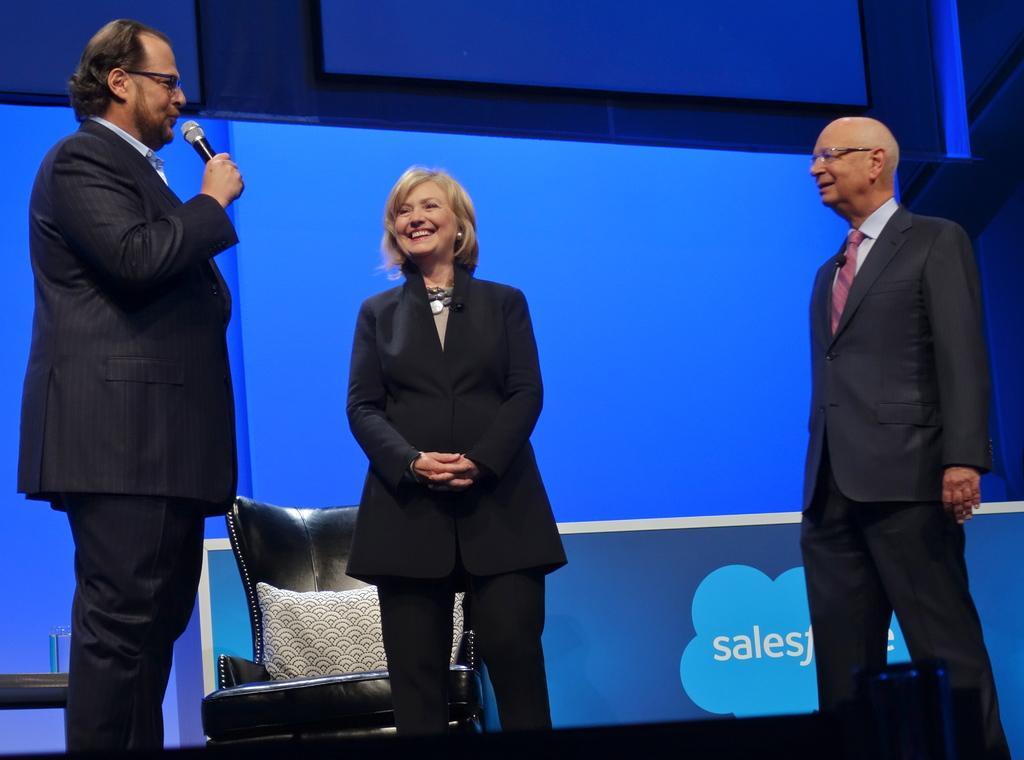Can you describe this image briefly? In the image there are three people standing in the foreground and the person standing on the left side is speaking something, behind the people there is an empty chair and in the background there is some text on a blue background. 